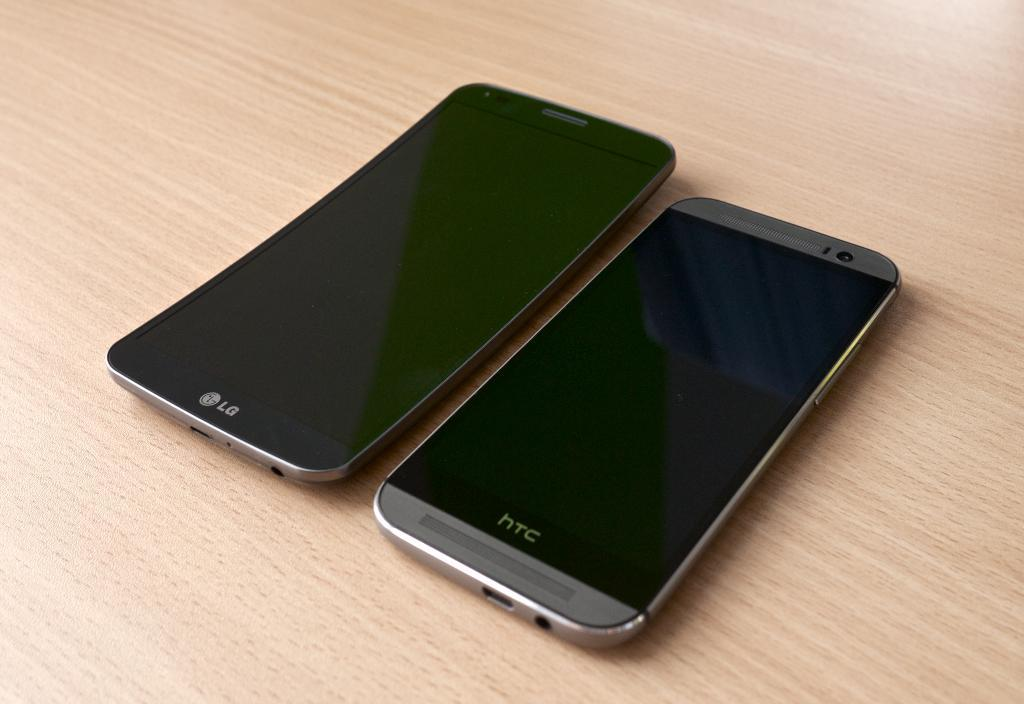<image>
Relay a brief, clear account of the picture shown. An LG cellphone is left of a HTC cellphone. 